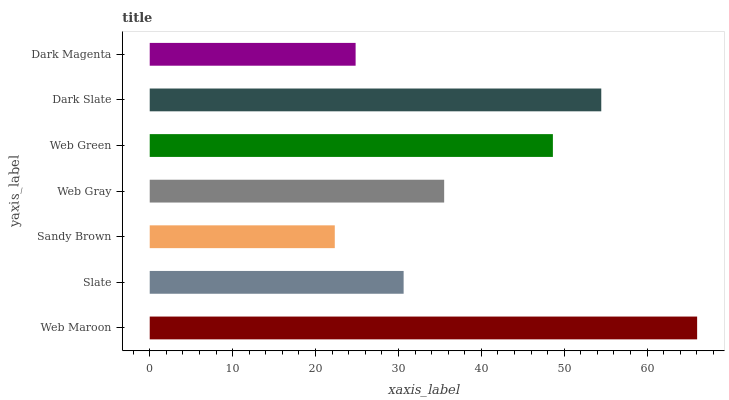Is Sandy Brown the minimum?
Answer yes or no. Yes. Is Web Maroon the maximum?
Answer yes or no. Yes. Is Slate the minimum?
Answer yes or no. No. Is Slate the maximum?
Answer yes or no. No. Is Web Maroon greater than Slate?
Answer yes or no. Yes. Is Slate less than Web Maroon?
Answer yes or no. Yes. Is Slate greater than Web Maroon?
Answer yes or no. No. Is Web Maroon less than Slate?
Answer yes or no. No. Is Web Gray the high median?
Answer yes or no. Yes. Is Web Gray the low median?
Answer yes or no. Yes. Is Dark Magenta the high median?
Answer yes or no. No. Is Web Green the low median?
Answer yes or no. No. 